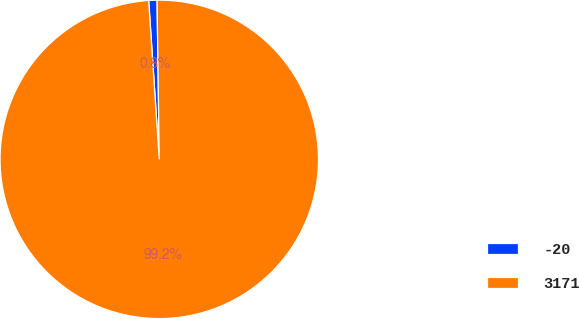Convert chart to OTSL. <chart><loc_0><loc_0><loc_500><loc_500><pie_chart><fcel>-20<fcel>3171<nl><fcel>0.84%<fcel>99.16%<nl></chart> 